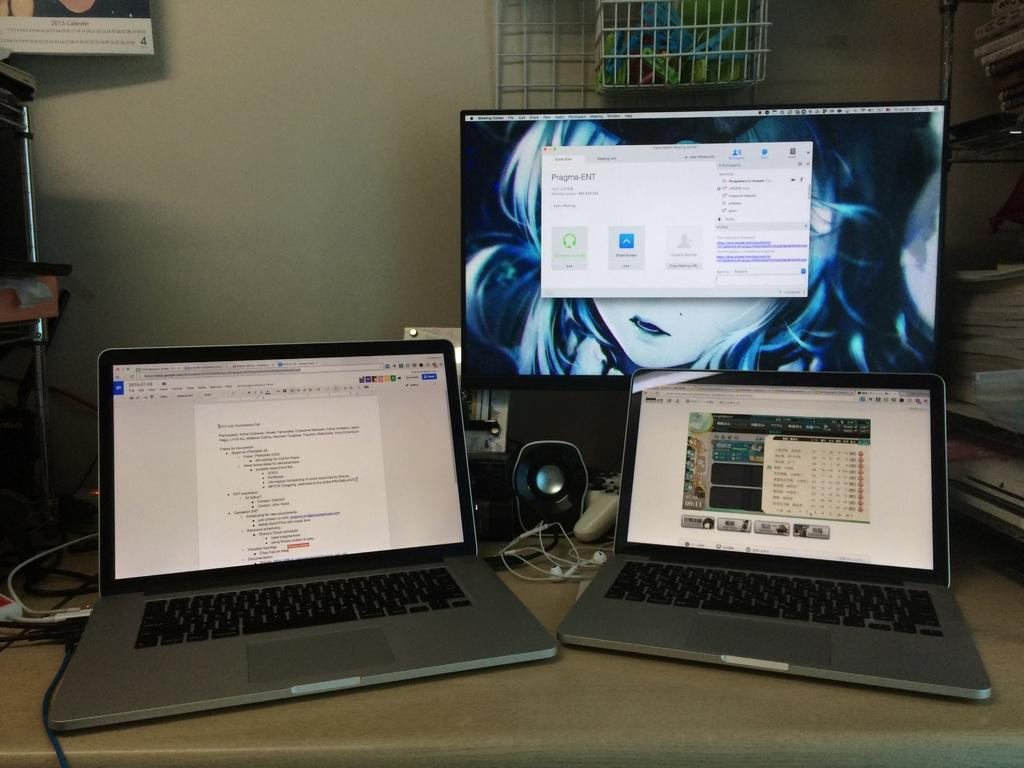How many laptops are visible in the image? There are two laptops in the image. What other electronic devices can be seen in the image? There is a monitor and a speaker visible in the image. What might be used for gaming in the image? There is a game controller in the image. What type of cream is being used to clean the board in the image? There is no board or cream present in the image. 